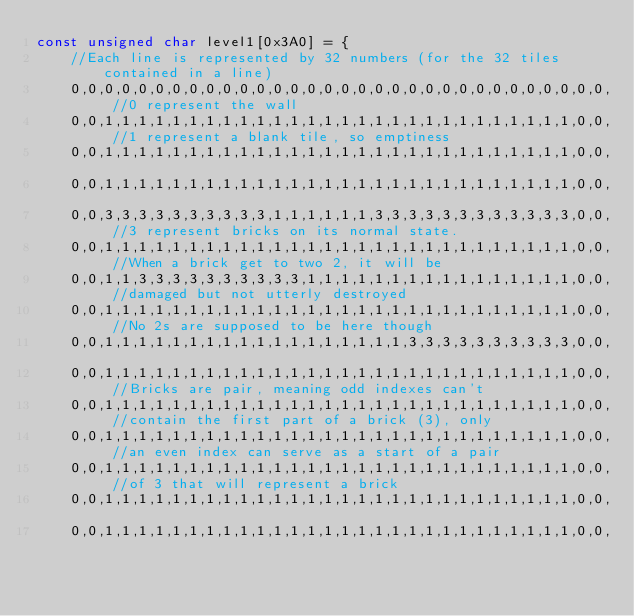Convert code to text. <code><loc_0><loc_0><loc_500><loc_500><_C_>const unsigned char level1[0x3A0] = {
    //Each line is represented by 32 numbers (for the 32 tiles contained in a line)
    0,0,0,0,0,0,0,0,0,0,0,0,0,0,0,0,0,0,0,0,0,0,0,0,0,0,0,0,0,0,0,0, //0 represent the wall
    0,0,1,1,1,1,1,1,1,1,1,1,1,1,1,1,1,1,1,1,1,1,1,1,1,1,1,1,1,1,0,0, //1 represent a blank tile, so emptiness
    0,0,1,1,1,1,1,1,1,1,1,1,1,1,1,1,1,1,1,1,1,1,1,1,1,1,1,1,1,1,0,0,
    0,0,1,1,1,1,1,1,1,1,1,1,1,1,1,1,1,1,1,1,1,1,1,1,1,1,1,1,1,1,0,0,
    0,0,3,3,3,3,3,3,3,3,3,3,1,1,1,1,1,1,3,3,3,3,3,3,3,3,3,3,3,3,0,0, //3 represent bricks on its normal state.
    0,0,1,1,1,1,1,1,1,1,1,1,1,1,1,1,1,1,1,1,1,1,1,1,1,1,1,1,1,1,0,0, //When a brick get to two 2, it will be
    0,0,1,1,3,3,3,3,3,3,3,3,3,3,1,1,1,1,1,1,1,1,1,1,1,1,1,1,1,1,0,0, //damaged but not utterly destroyed
    0,0,1,1,1,1,1,1,1,1,1,1,1,1,1,1,1,1,1,1,1,1,1,1,1,1,1,1,1,1,0,0, //No 2s are supposed to be here though
    0,0,1,1,1,1,1,1,1,1,1,1,1,1,1,1,1,1,1,1,3,3,3,3,3,3,3,3,3,3,0,0,
    0,0,1,1,1,1,1,1,1,1,1,1,1,1,1,1,1,1,1,1,1,1,1,1,1,1,1,1,1,1,0,0, //Bricks are pair, meaning odd indexes can't
    0,0,1,1,1,1,1,1,1,1,1,1,1,1,1,1,1,1,1,1,1,1,1,1,1,1,1,1,1,1,0,0, //contain the first part of a brick (3), only
    0,0,1,1,1,1,1,1,1,1,1,1,1,1,1,1,1,1,1,1,1,1,1,1,1,1,1,1,1,1,0,0, //an even index can serve as a start of a pair
    0,0,1,1,1,1,1,1,1,1,1,1,1,1,1,1,1,1,1,1,1,1,1,1,1,1,1,1,1,1,0,0, //of 3 that will represent a brick
    0,0,1,1,1,1,1,1,1,1,1,1,1,1,1,1,1,1,1,1,1,1,1,1,1,1,1,1,1,1,0,0,
    0,0,1,1,1,1,1,1,1,1,1,1,1,1,1,1,1,1,1,1,1,1,1,1,1,1,1,1,1,1,0,0,</code> 